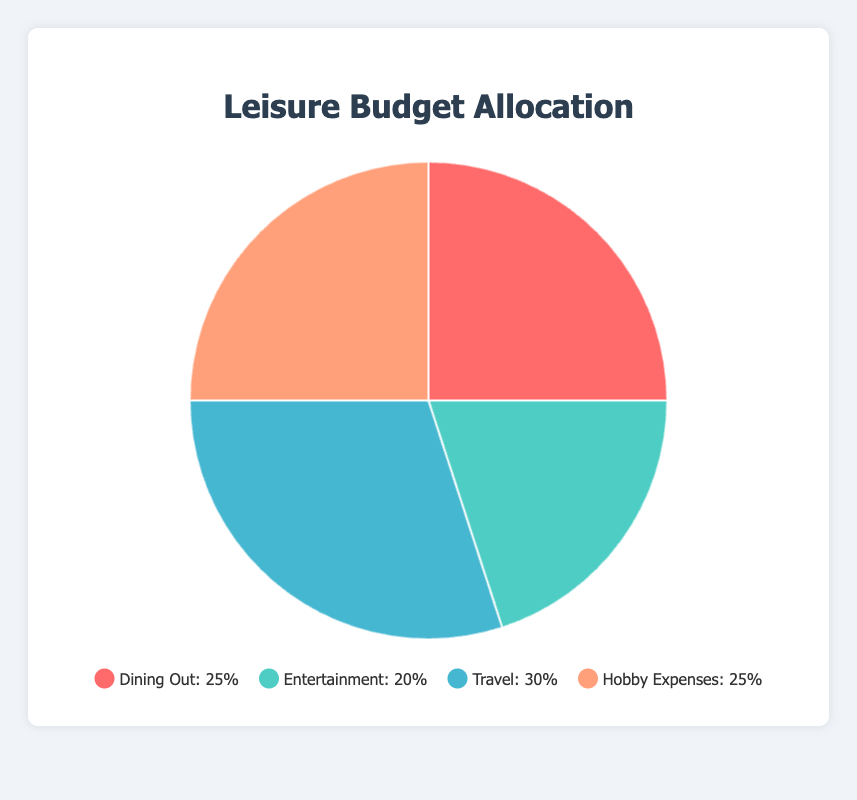what percentage of the household budget is allocated to travel? The travel category is represented as a segment of the pie chart. According to the data provided, the percentage is 30.
Answer: 30% which category has the smallest allocation in the household budget? By comparing all the segments in the pie chart, the category with the smallest percentage is Entertainment at 20%.
Answer: Entertainment how much more is allocated to dining out compared to entertainment? Dining Out is allocated 25%, and Entertainment is allocated 20%. Subtracting the two percentages gives 25% - 20% = 5%.
Answer: 5% are hobby expenses and dining out equally allocated in the household budget? Both Dining Out and Hobby Expenses are represented by segments that have the same percentage allocation in the pie chart. According to the data, they are each at 25%.
Answer: Yes what is the combined percentage allocation for dining out and hobby expenses? Adding the percentages for Dining Out (25%) and Hobby Expenses (25%) results in a combined allocation of 25% + 25% = 50%.
Answer: 50% compare the budget allocation for travel and entertainment. Which one is greater? In the pie chart, travel is allocated 30% and entertainment is allocated 20%. Therefore, travel has a greater allocation.
Answer: Travel what percentage of the budget is allocated to categories other than entertainment? The total budget percentage is 100%. Subtracting the Entertainment allocation (20%), the remaining percentage is 100% - 20% = 80%.
Answer: 80% which segment of the pie chart represents 25% of the household budget, and can you name these categories? In the pie chart, the segments that represent 25% each are the categories for Dining Out and Hobby Expenses.
Answer: Dining Out and Hobby Expenses if hobby expenses were reduced by 5% and travel increased by the same amount, what would be their new percentages? Currently, Hobby Expenses is 25% and Travel is 30%. Reducing Hobby Expenses by 5% gives 25% - 5% = 20%. Increasing Travel by 5% gives 30% + 5% = 35%.
Answer: Hobby Expenses: 20%, Travel: 35% how much higher is the allocation for travel compared to the average allocation of the three other categories? The average allocation of Dining Out, Entertainment, and Hobby Expenses is (25% + 20% + 25%) / 3 = 23.33%. The Travel allocation is 30%. The difference is 30% - 23.33% = 6.67%.
Answer: 6.67% 